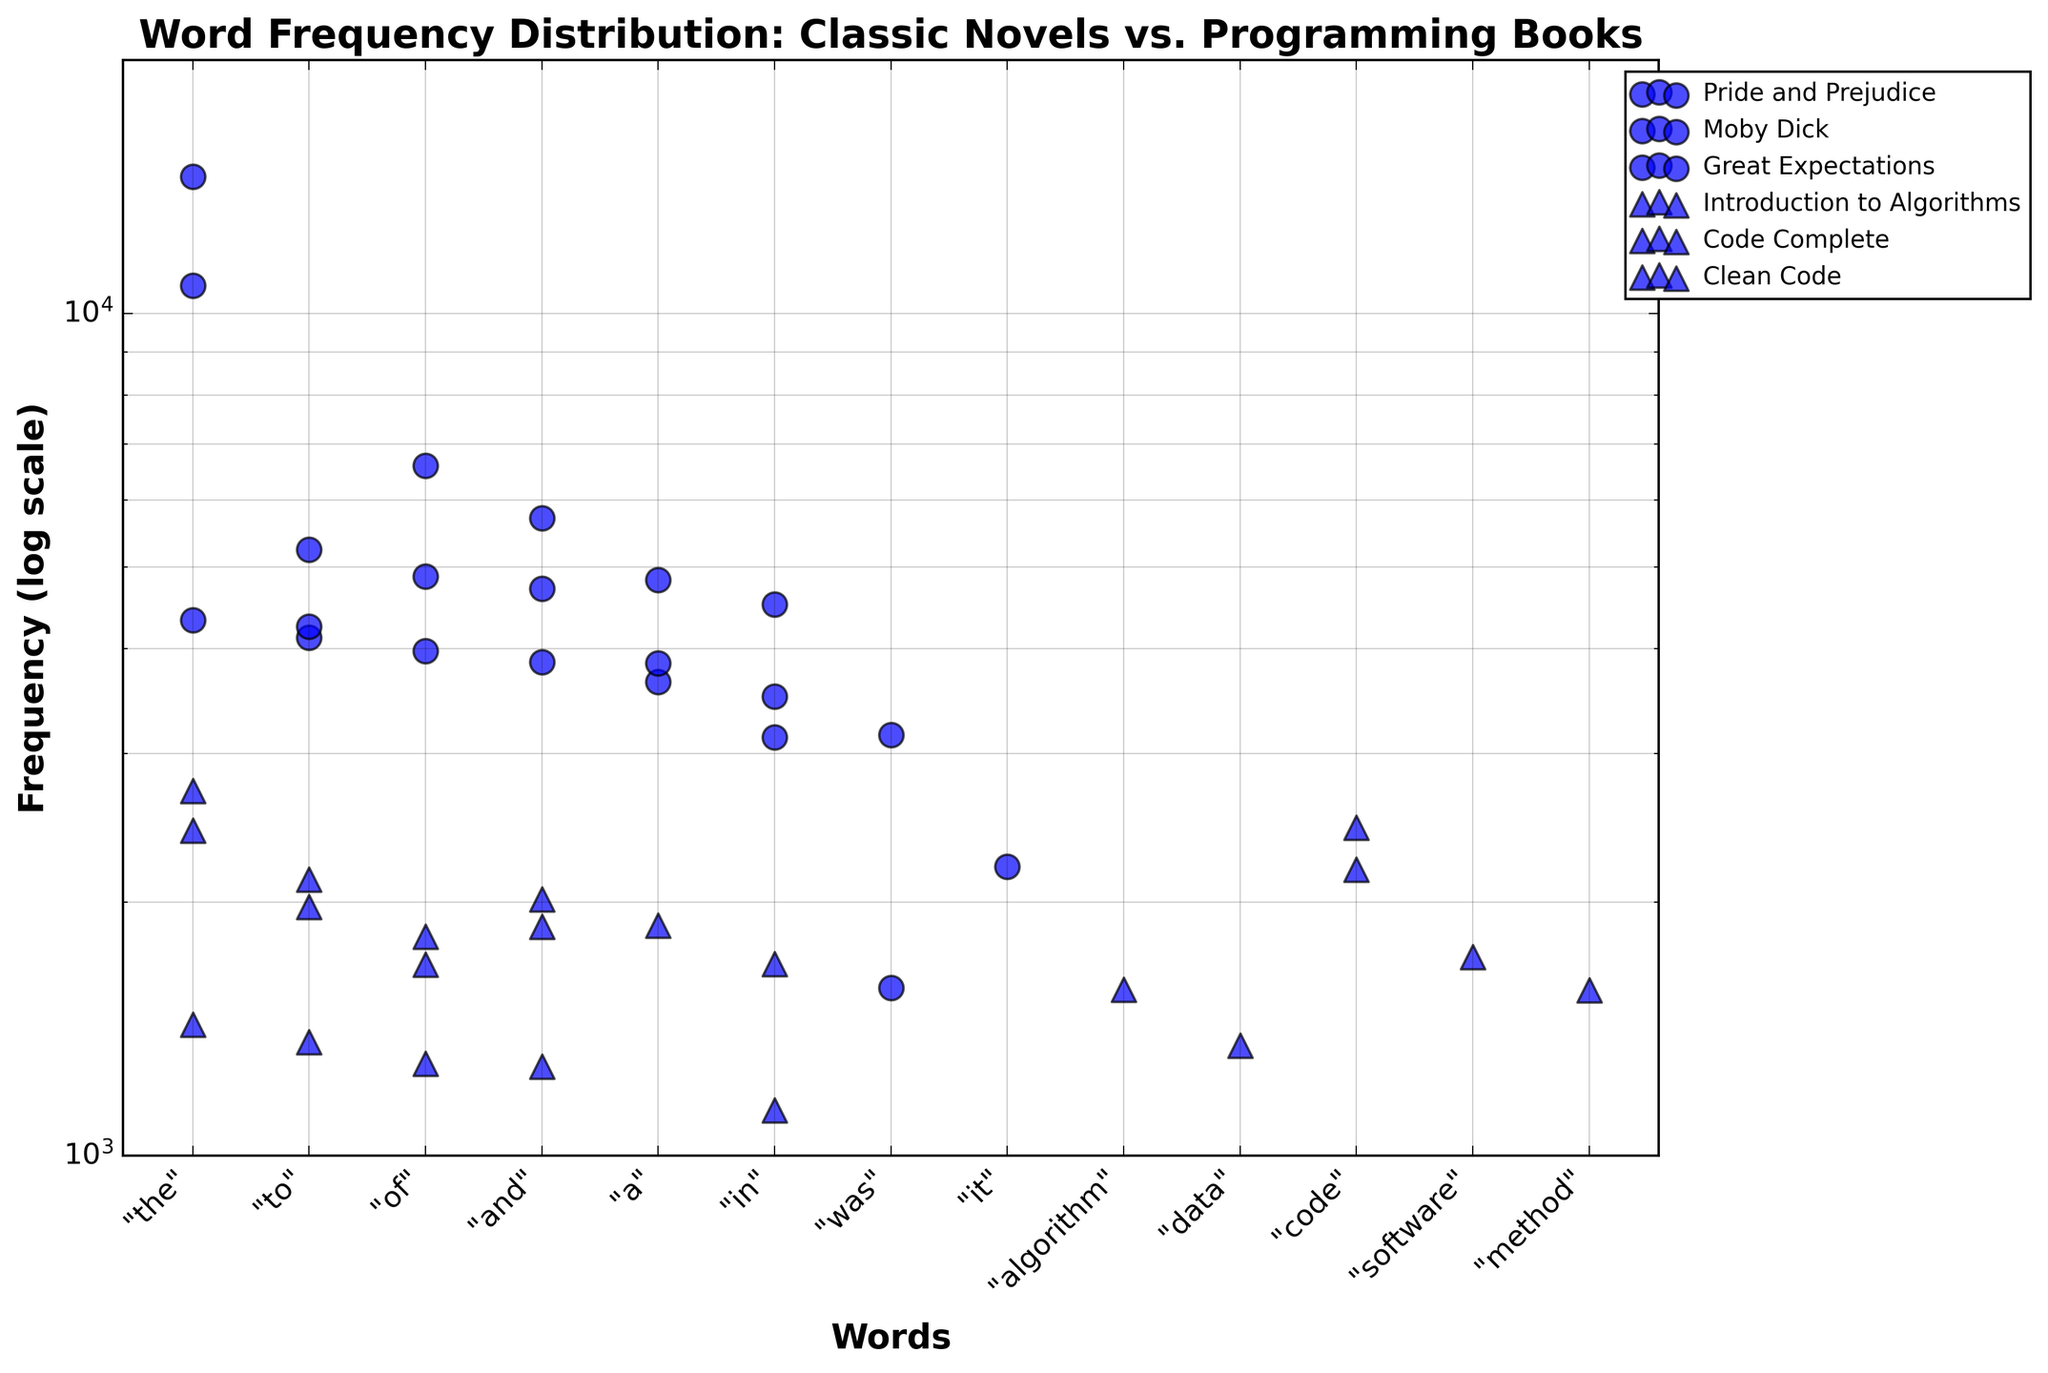What's the overall title of the figure? The title is generally placed at the top of the figure and provides an overview of what the figure is about. In this case, the title is indicating a comparison of word frequency distributions between classic novels and programming books.
Answer: Word Frequency Distribution: Classic Novels vs. Programming Books What axis scale is used for the frequency? By observing the y-axis labels and their interval, it's clear that they follow a logarithmic scale, which means the axis increases by orders of magnitude (e.g., 1000, 10000). This is common for visualizing distributions with large range differences.
Answer: Logarithmic scale What shapes are used to represent classic novels and programming books? The figure uses different markers to differentiate between the two categories. In this case, circles (o) are used for classic novels, and triangles (^) are used for programming books.
Answer: Circles for classic novels and triangles for programming books Which word appears most frequently in "Pride and Prejudice"? Look at the "Pride and Prejudice" data points and identify the one with the highest position on the y-axis. The word at the top (since the y-axis is on a log scale) appears most frequently.
Answer: "the" Comparing "the" in "Clean Code" and "the" in "Code Complete," which book uses this word more frequently? Look for the y-axis positions of the word "the" in both "Clean Code" and "Code Complete". The higher point indicates greater frequency.
Answer: "Clean Code" Between "Moby Dick" and "Great Expectations," which novel has a higher frequency for the word "the"? Identify the data points representing the word "the" for both novels. The point higher on the y-axis shows the novel with a higher frequency.
Answer: Moby Dick In "Introduction to Algorithms," which word has the highest frequency? Check the data points for "Introduction to Algorithms" and find the highest one. The corresponding word is the one with the highest frequency.
Answer: algorithm Is the word "and" used more frequently in "Moby Dick" or "Code Complete"? Compare the y-axis positions of the word "and" in "Moby Dick" and "Code Complete". The higher point shows the book with the greater frequency.
Answer: Moby Dick What's the minimum value on the y-axis? The y-axis range can be identified at the lower end. It starts from 1000 as indicated in the generation settings and axis labels.
Answer: 1000 